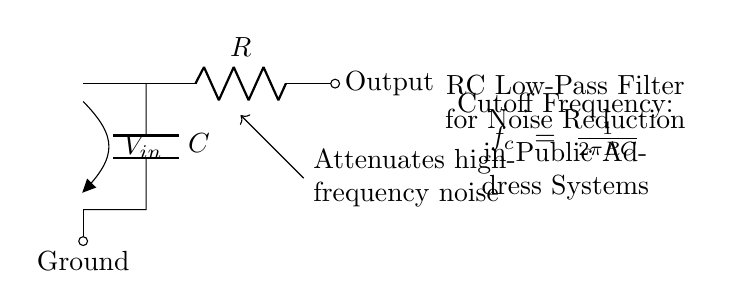What are the components in the circuit? The circuit has a resistor (R) and a capacitor (C) as its main components, which are part of the RC low-pass filter configuration.
Answer: Resistor and Capacitor What is the purpose of the circuit? The circuit is designed to attenuate high-frequency noise in public address systems, making sounds clearer during local gatherings.
Answer: Noise reduction What is the output connection labeled as? The output of the circuit is labeled simply as "Output," indicating where the filtered signal is taken from.
Answer: Output What does the cutoff frequency formula represent? The cutoff frequency formula \( f_c = \frac{1}{2\pi RC} \) represents the frequency at which the output voltage is reduced to 70.7% of the input voltage, effectively defining the filter's performance.
Answer: Cutoff frequency How does this circuit achieve noise reduction? The RC low-pass filter works by allowing low-frequency signals to pass while attenuating higher-frequency noise, which is essential in communication systems like public address setups.
Answer: Attenuates high frequencies What would happen if the resistance value is increased? Increasing the resistance would lower the cutoff frequency, meaning that the circuit would allow lower frequencies to pass while further reducing the high-frequency noise.
Answer: Lower cutoff frequency What type of filter is illustrated in the circuit diagram? The circuit diagram illustrates a low-pass filter, specifically an RC low-pass filter, since it allows low frequencies to pass through while blocking higher frequencies.
Answer: Low-pass filter 